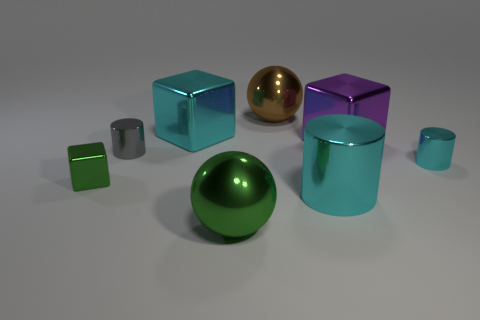Add 1 small red metal spheres. How many objects exist? 9 Subtract all cubes. How many objects are left? 5 Subtract all large red balls. Subtract all green spheres. How many objects are left? 7 Add 1 gray metal cylinders. How many gray metal cylinders are left? 2 Add 3 big shiny spheres. How many big shiny spheres exist? 5 Subtract 0 blue spheres. How many objects are left? 8 